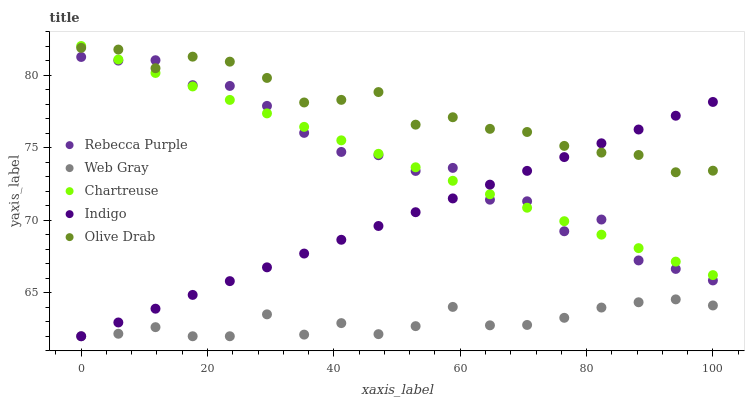Does Web Gray have the minimum area under the curve?
Answer yes or no. Yes. Does Olive Drab have the maximum area under the curve?
Answer yes or no. Yes. Does Indigo have the minimum area under the curve?
Answer yes or no. No. Does Indigo have the maximum area under the curve?
Answer yes or no. No. Is Chartreuse the smoothest?
Answer yes or no. Yes. Is Rebecca Purple the roughest?
Answer yes or no. Yes. Is Web Gray the smoothest?
Answer yes or no. No. Is Web Gray the roughest?
Answer yes or no. No. Does Web Gray have the lowest value?
Answer yes or no. Yes. Does Rebecca Purple have the lowest value?
Answer yes or no. No. Does Chartreuse have the highest value?
Answer yes or no. Yes. Does Indigo have the highest value?
Answer yes or no. No. Is Web Gray less than Chartreuse?
Answer yes or no. Yes. Is Olive Drab greater than Web Gray?
Answer yes or no. Yes. Does Indigo intersect Chartreuse?
Answer yes or no. Yes. Is Indigo less than Chartreuse?
Answer yes or no. No. Is Indigo greater than Chartreuse?
Answer yes or no. No. Does Web Gray intersect Chartreuse?
Answer yes or no. No. 